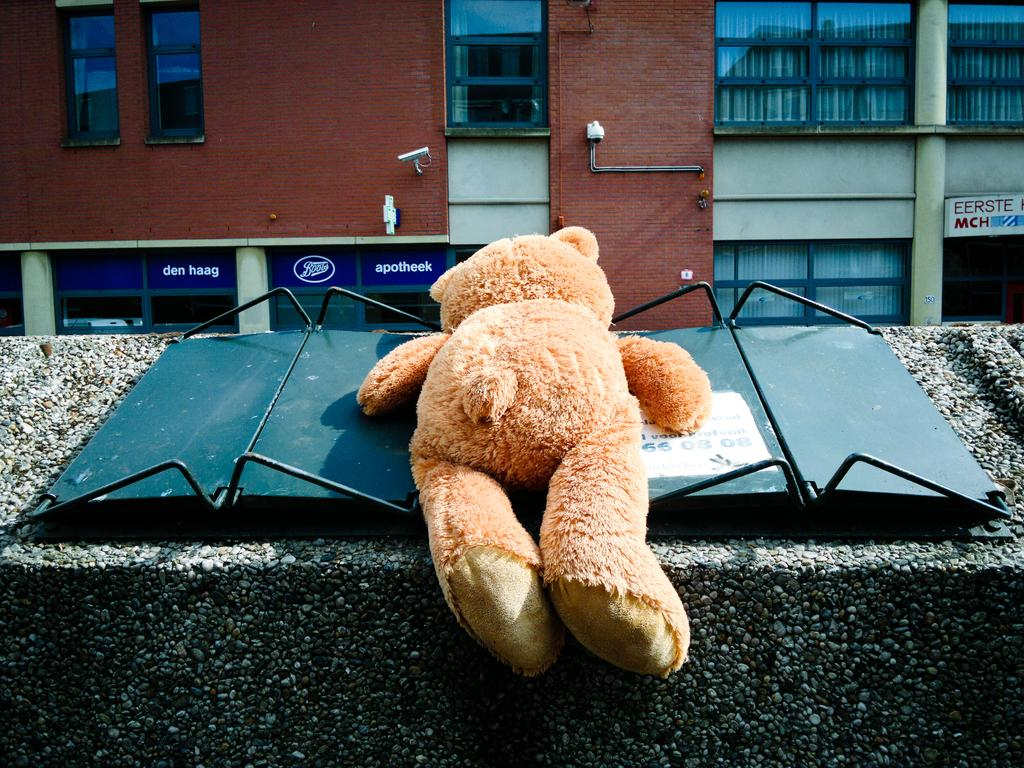What object is placed on a platform in the image? There is a toy on a platform in the image. What can be seen in the background of the image? There is a building, glasses, and boards in the background of the image. What type of secretary can be seen working in the image? There is no secretary present in the image. What is the name of the thing that is not visible in the image? It is impossible to answer this question, as the image does not contain any "thing" that is not visible. 